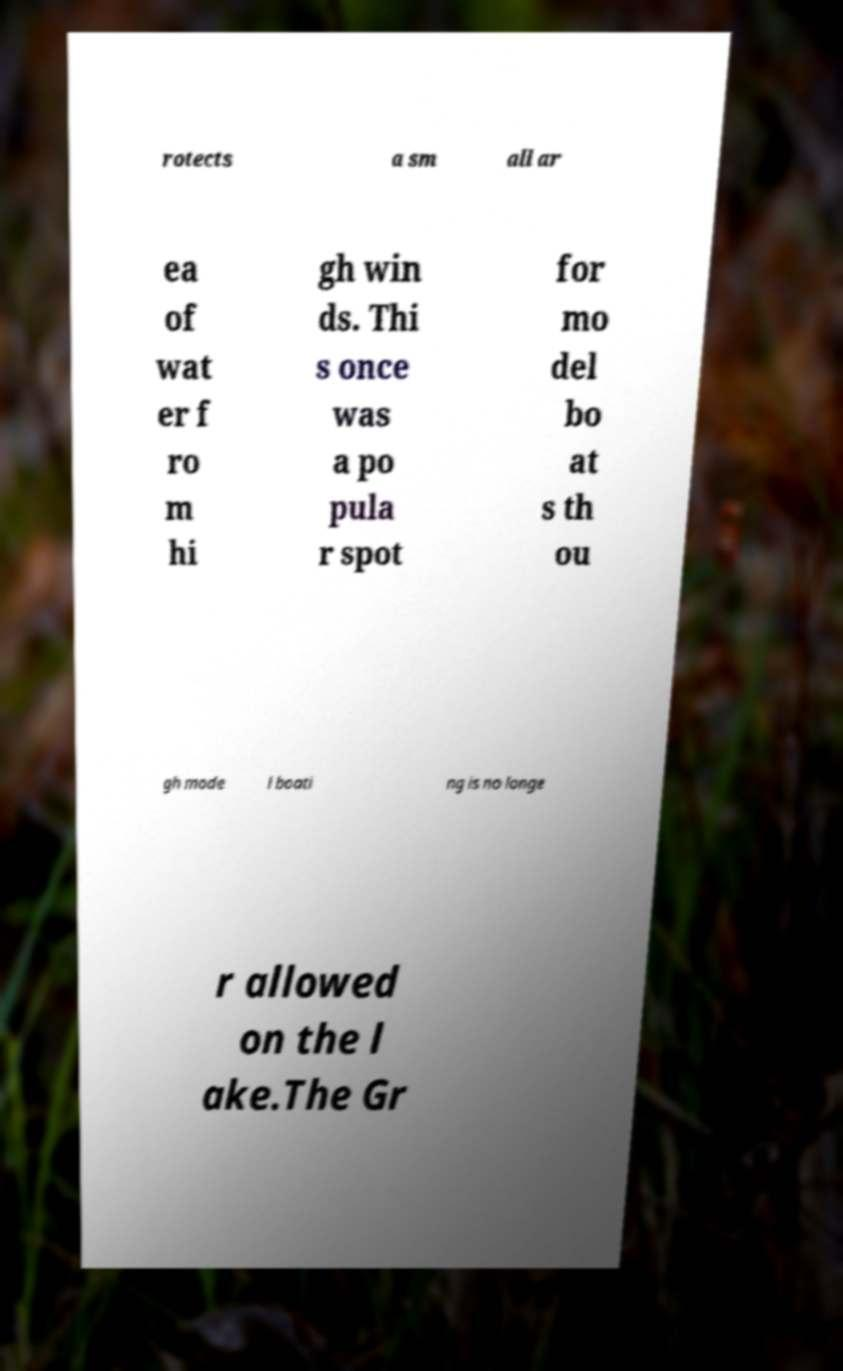Can you accurately transcribe the text from the provided image for me? rotects a sm all ar ea of wat er f ro m hi gh win ds. Thi s once was a po pula r spot for mo del bo at s th ou gh mode l boati ng is no longe r allowed on the l ake.The Gr 